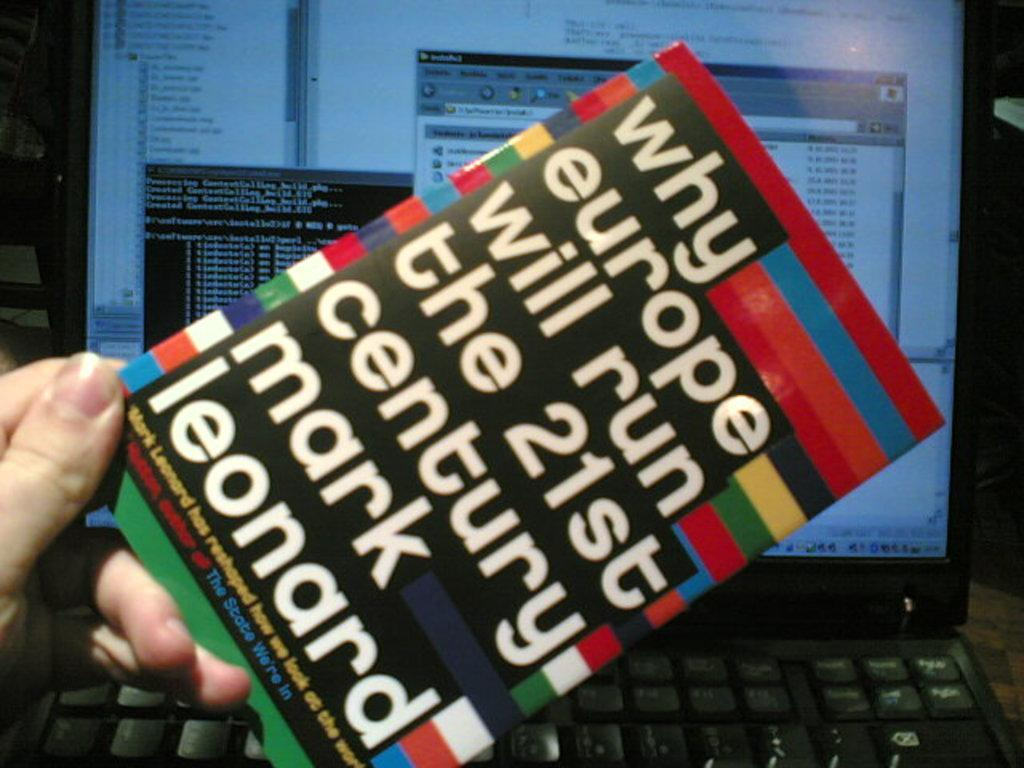<image>
Provide a brief description of the given image. A book being held infront of a computer titled Why Europe Will Run the 21st Century. 